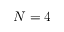<formula> <loc_0><loc_0><loc_500><loc_500>N = 4</formula> 